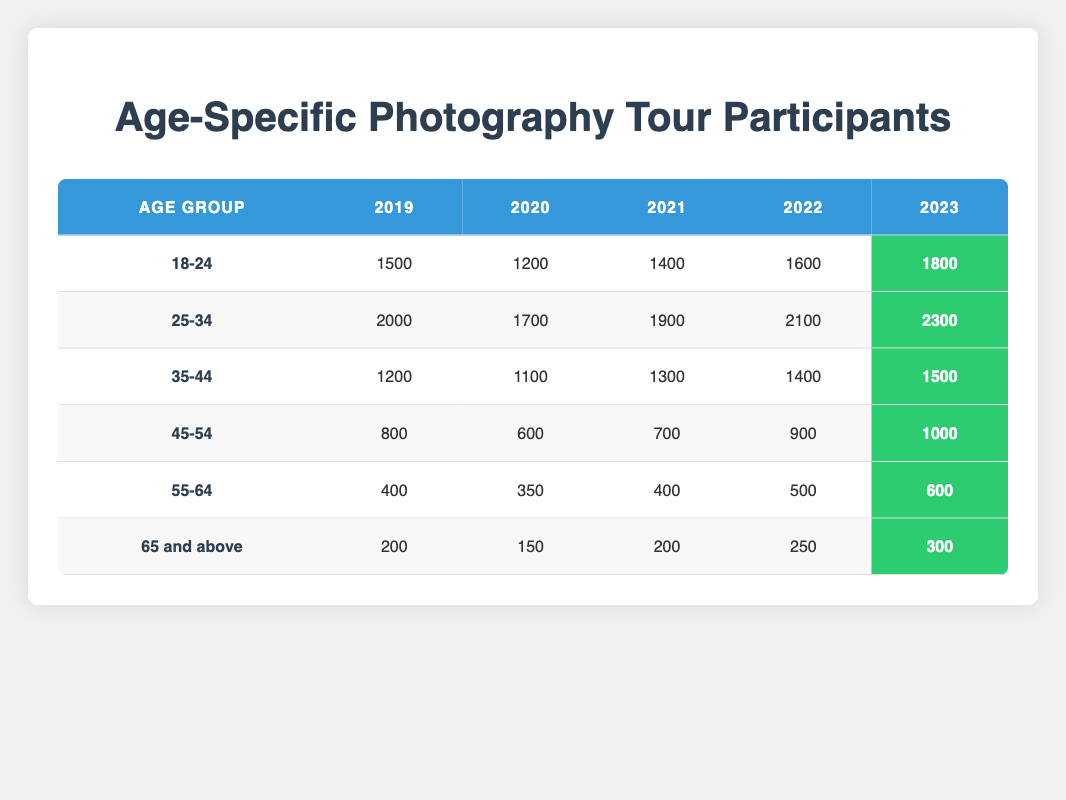What age group had the highest number of participants in 2023? By looking at the last column in the table for the year 2023, the age group with the highest number is "25-34," which had 2300 participants.
Answer: 25-34 How many participants were there in the age group 45-54 in 2021? Referring to the data for the age group "45-54" and looking at the column for the year 2021, there were 700 participants.
Answer: 700 What is the total number of participants from the age group 18-24 over the five years? To find the total, sum the participants from the five years for the age group "18-24": 1500 + 1200 + 1400 + 1600 + 1800 = 8300.
Answer: 8300 Did the number of participants aged 65 and above increase every year? Checking the yearly data for the age group "65 and above," the numbers are 200, 150, 200, 250, and 300. Since the numbers decreased from 2019 to 2020, the statement is false.
Answer: No What was the average number of participants in the age group 55-64 over the five years? To calculate the average for the age group "55-64," sum the participants over the five years: 400 + 350 + 400 + 500 + 600 = 2250. Then, divide by the number of years, which is 5, giving an average of 450.
Answer: 450 How many more participants were in the age group 25-34 compared to 35-44 in 2022? In 2022, the number of participants for "25-34" was 2100, and for "35-44," it was 1400. The difference is 2100 - 1400 = 700.
Answer: 700 What percentage of the total participants in 2023 were from the age group 55-64? In 2023, the total number of participants is 1800 (18-24) + 2300 (25-34) + 1500 (35-44) + 1000 (45-54) + 600 (55-64) + 300 (65 and above) = 8300. For age group "55-64," there were 600 participants, so (600 / 8300) * 100 = roughly 7.23%.
Answer: 7.23% What year did the age group 45-54 see the lowest participation? Looking at the data for "45-54," the years show 800, 600, 700, 900, and 1000 participants. The lowest was in 2020 with 600 participants.
Answer: 2020 Which age group had the most significant increase in participants from 2020 to 2023? Comparing the participants for each age group from 2020 to 2023: "18-24" increased by 600, "25-34" by 600, "35-44" by 400, "45-54" by 400, "55-64" by 250, and "65 and above" by 150. The age groups "18-24" and "25-34" both had the same increase of 600.
Answer: 18-24 and 25-34 